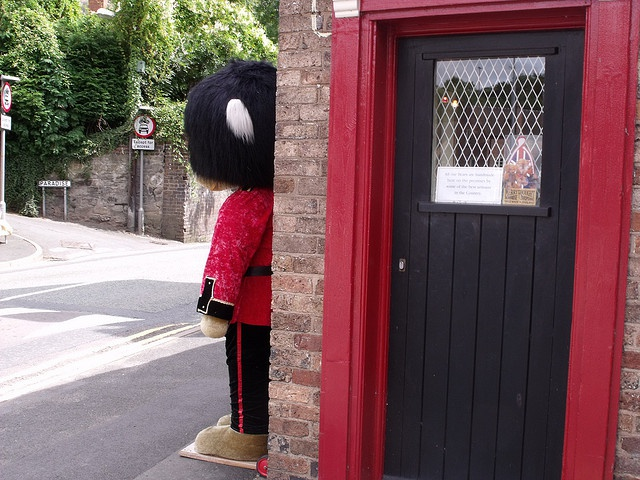Describe the objects in this image and their specific colors. I can see a teddy bear in darkgreen, black, brown, maroon, and gray tones in this image. 